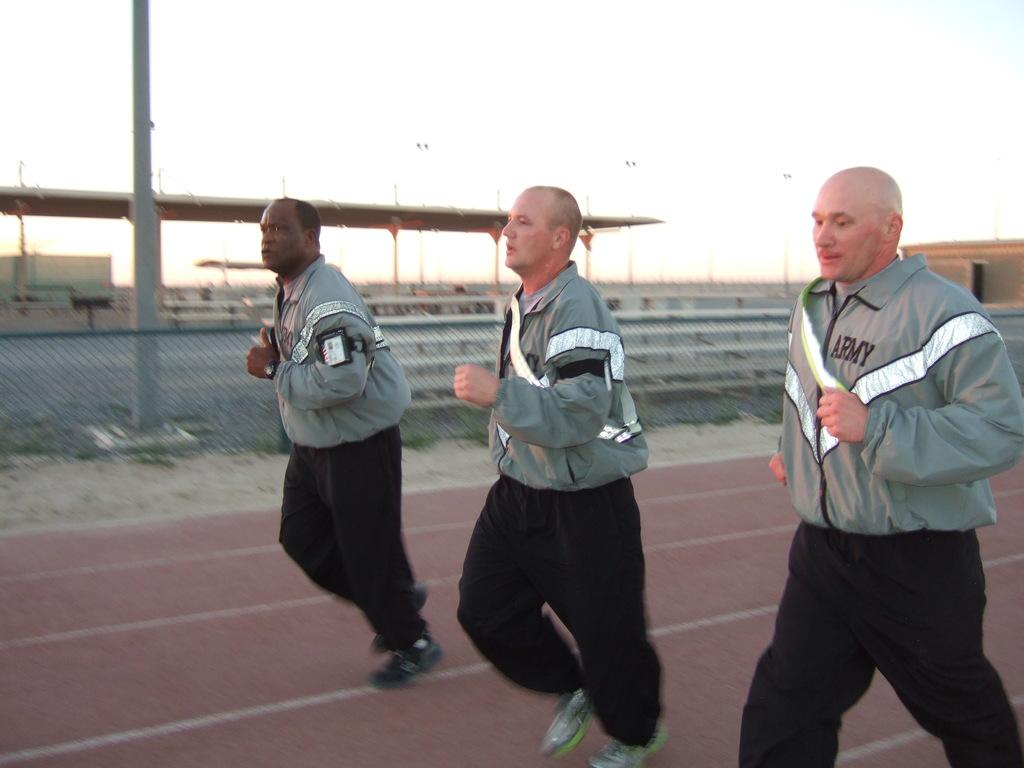What are the three men in the image doing? The three men are running in the image. On what surface are the men running? The men are running on the ground. What can be seen in the background of the image? There are fences, poles, and at least one building on each side of the image. What part of the natural environment is visible in the image? The sky is visible in the background of the image. What type of bottle can be seen being pushed by one of the men in the image? There is no bottle present in the image, nor is any man pushing a bottle. 